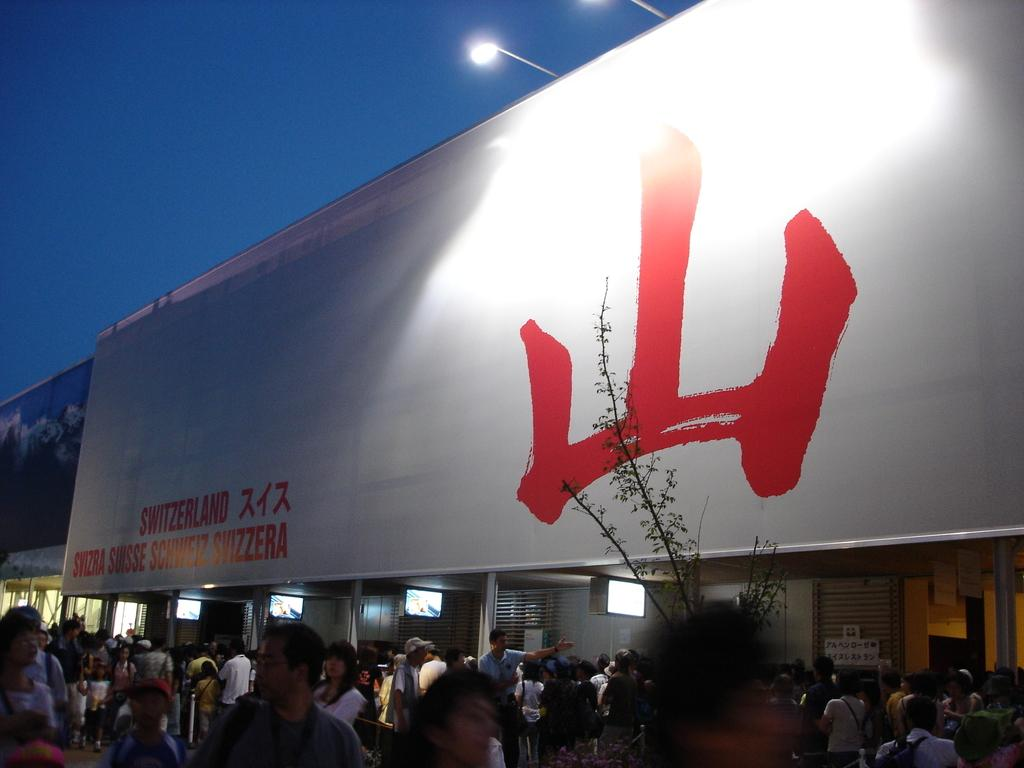What is located in the foreground of the image? There are people in the foreground of the image. What can be seen in the middle of the image? There are banners and lights in the middle of the image, as well as a plant. What is visible at the top of the image? The sky is visible at the top of the image. Is there a spy observing the people in the foreground of the image? There is no indication of a spy in the image; it only shows people, banners, lights, a plant, and the sky. Can you see a horse in the middle of the image? There is no horse present in the image; it features banners, lights, and a plant. 